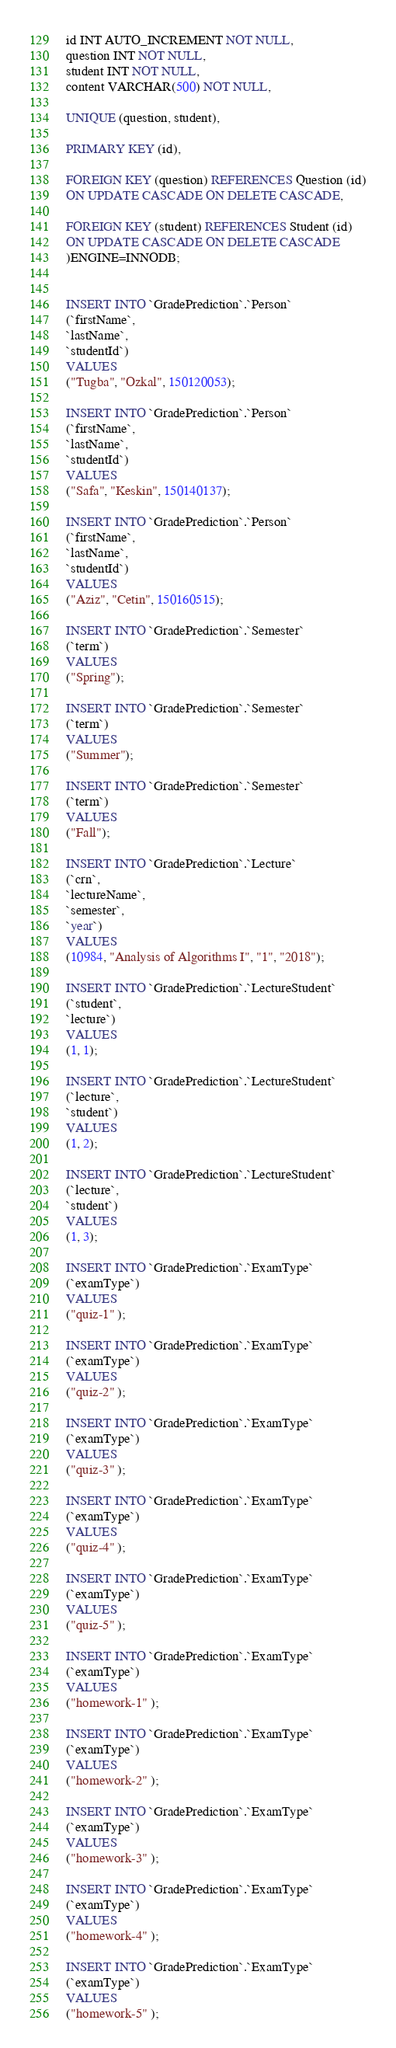<code> <loc_0><loc_0><loc_500><loc_500><_SQL_>id INT AUTO_INCREMENT NOT NULL,
question INT NOT NULL,
student INT NOT NULL,
content VARCHAR(500) NOT NULL,

UNIQUE (question, student),

PRIMARY KEY (id),

FOREIGN KEY (question) REFERENCES Question (id)
ON UPDATE CASCADE ON DELETE CASCADE,

FOREIGN KEY (student) REFERENCES Student (id)
ON UPDATE CASCADE ON DELETE CASCADE
)ENGINE=INNODB;


INSERT INTO `GradePrediction`.`Person`
(`firstName`,
`lastName`,
`studentId`)
VALUES
("Tugba", "Ozkal", 150120053);

INSERT INTO `GradePrediction`.`Person`
(`firstName`,
`lastName`,
`studentId`)
VALUES
("Safa", "Keskin", 150140137);

INSERT INTO `GradePrediction`.`Person`
(`firstName`,
`lastName`,
`studentId`)
VALUES
("Aziz", "Cetin", 150160515);

INSERT INTO `GradePrediction`.`Semester`
(`term`)
VALUES
("Spring");

INSERT INTO `GradePrediction`.`Semester`
(`term`)
VALUES
("Summer");

INSERT INTO `GradePrediction`.`Semester`
(`term`)
VALUES
("Fall");

INSERT INTO `GradePrediction`.`Lecture`
(`crn`,
`lectureName`,
`semester`,
`year`)
VALUES
(10984, "Analysis of Algorithms I", "1", "2018");

INSERT INTO `GradePrediction`.`LectureStudent`
(`student`,
`lecture`)
VALUES
(1, 1);

INSERT INTO `GradePrediction`.`LectureStudent`
(`lecture`,
`student`)
VALUES
(1, 2);

INSERT INTO `GradePrediction`.`LectureStudent`
(`lecture`,
`student`)
VALUES
(1, 3);

INSERT INTO `GradePrediction`.`ExamType`
(`examType`)
VALUES
("quiz-1" );

INSERT INTO `GradePrediction`.`ExamType`
(`examType`)
VALUES
("quiz-2" );

INSERT INTO `GradePrediction`.`ExamType`
(`examType`)
VALUES
("quiz-3" );

INSERT INTO `GradePrediction`.`ExamType`
(`examType`)
VALUES
("quiz-4" );

INSERT INTO `GradePrediction`.`ExamType`
(`examType`)
VALUES
("quiz-5" );

INSERT INTO `GradePrediction`.`ExamType`
(`examType`)
VALUES
("homework-1" );

INSERT INTO `GradePrediction`.`ExamType`
(`examType`)
VALUES
("homework-2" );

INSERT INTO `GradePrediction`.`ExamType`
(`examType`)
VALUES
("homework-3" );

INSERT INTO `GradePrediction`.`ExamType`
(`examType`)
VALUES
("homework-4" );

INSERT INTO `GradePrediction`.`ExamType`
(`examType`)
VALUES
("homework-5" );
</code> 